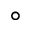Convert formula to latex. <formula><loc_0><loc_0><loc_500><loc_500>\circ</formula> 